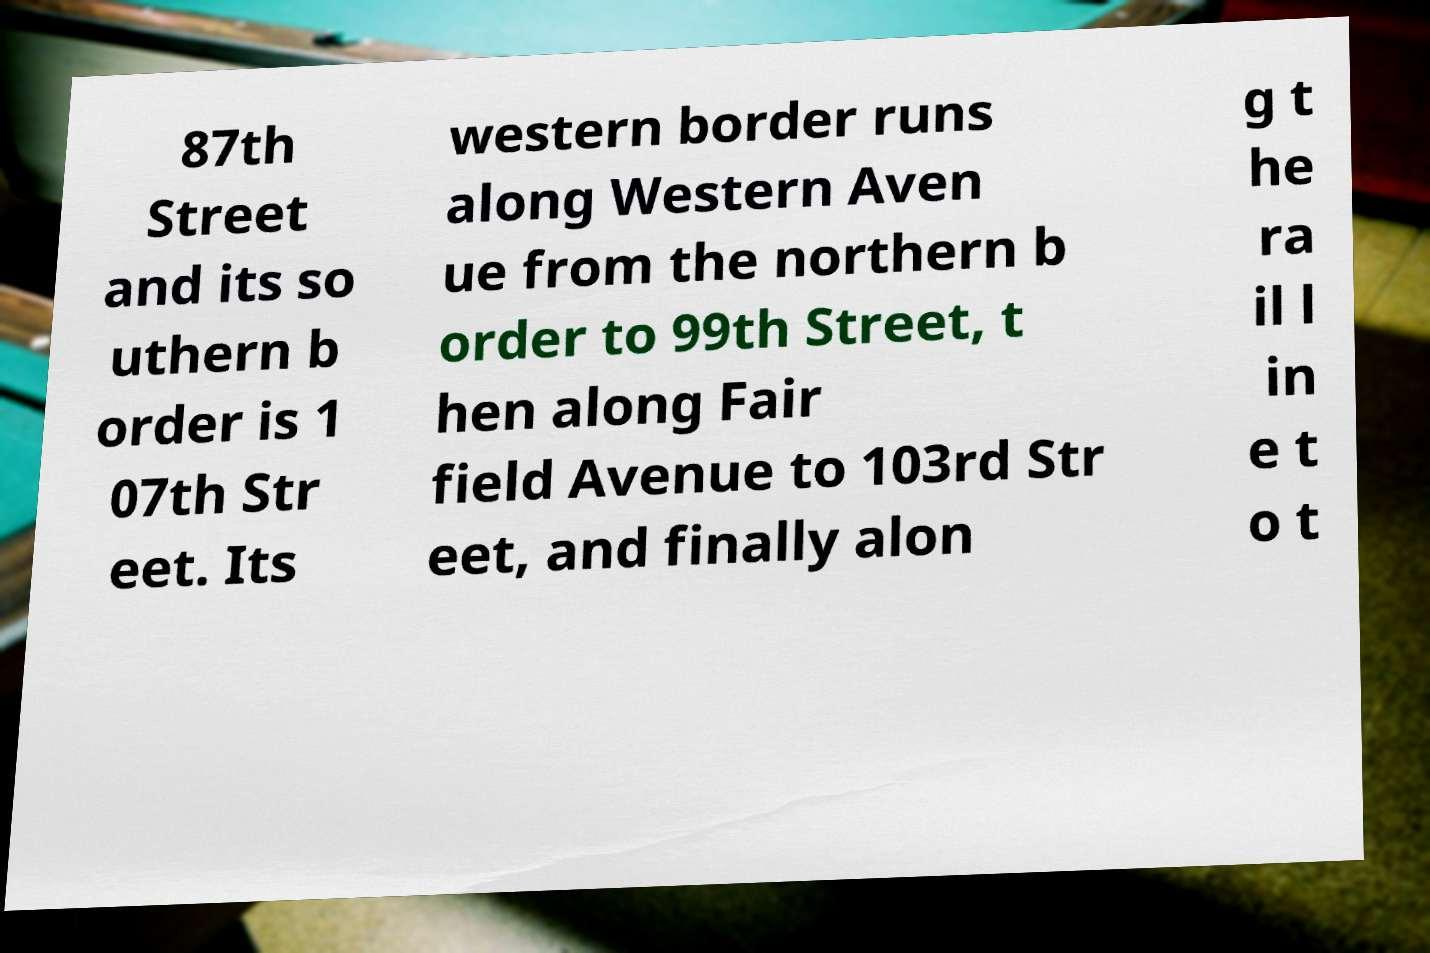Please identify and transcribe the text found in this image. 87th Street and its so uthern b order is 1 07th Str eet. Its western border runs along Western Aven ue from the northern b order to 99th Street, t hen along Fair field Avenue to 103rd Str eet, and finally alon g t he ra il l in e t o t 